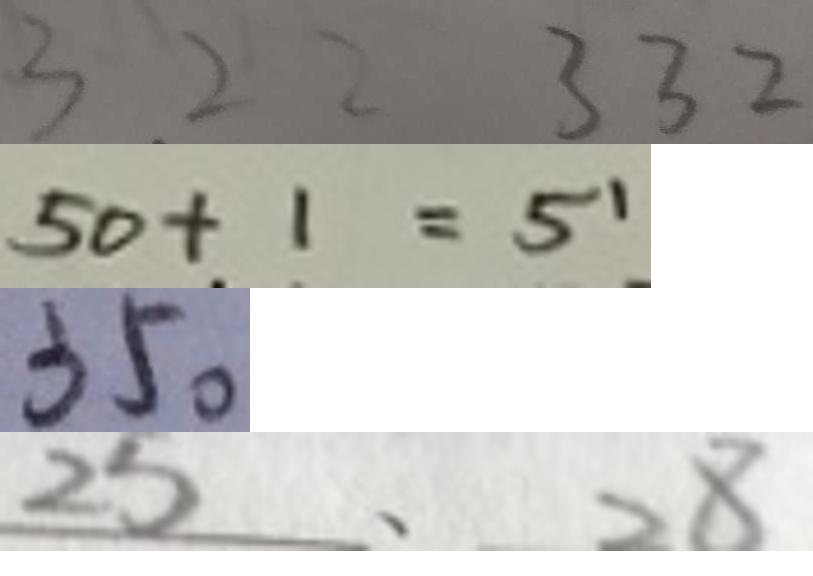<formula> <loc_0><loc_0><loc_500><loc_500>3 2 2 3 3 2 
 5 0 + 1 = 5 1 
 3 5 0 
 2 5 、 2 8</formula> 